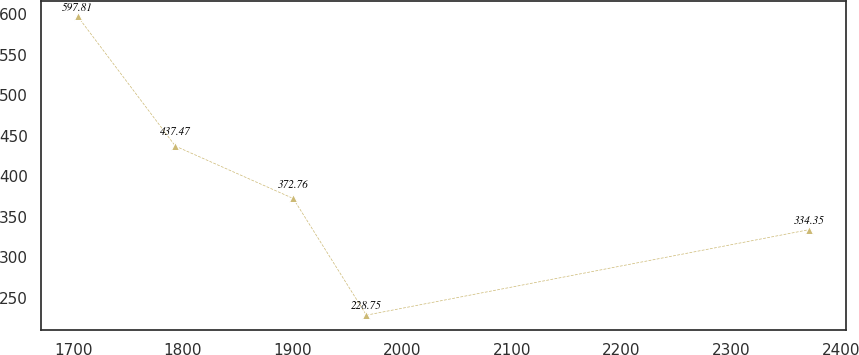<chart> <loc_0><loc_0><loc_500><loc_500><line_chart><ecel><fcel>Unnamed: 1<nl><fcel>1703.97<fcel>597.81<nl><fcel>1793.18<fcel>437.47<nl><fcel>1900.69<fcel>372.76<nl><fcel>1967.45<fcel>228.75<nl><fcel>2371.52<fcel>334.35<nl></chart> 